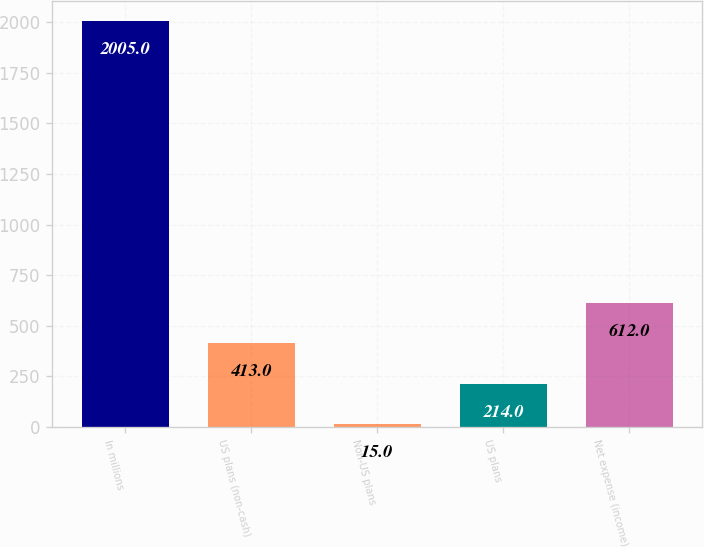Convert chart. <chart><loc_0><loc_0><loc_500><loc_500><bar_chart><fcel>In millions<fcel>US plans (non-cash)<fcel>Non-US plans<fcel>US plans<fcel>Net expense (income)<nl><fcel>2005<fcel>413<fcel>15<fcel>214<fcel>612<nl></chart> 